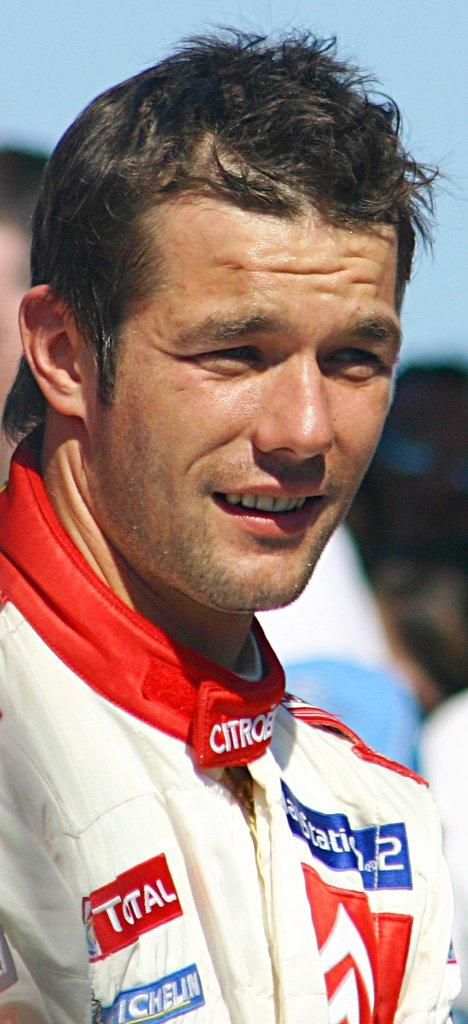<image>
Relay a brief, clear account of the picture shown. A man with a red badge on his jacket that includes the word "total" squints in bright sunlight. 